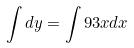Convert formula to latex. <formula><loc_0><loc_0><loc_500><loc_500>\int d y = \int 9 3 x d x</formula> 